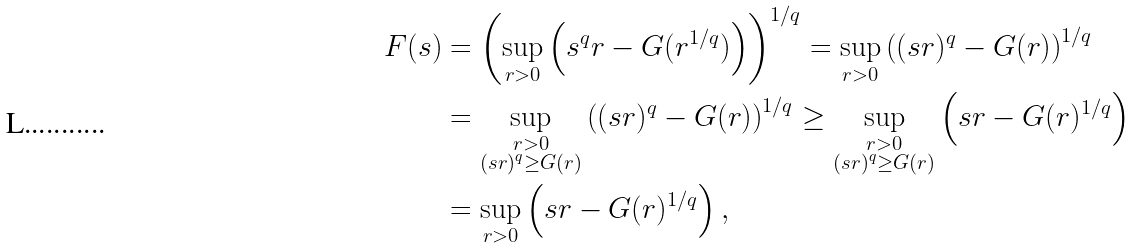Convert formula to latex. <formula><loc_0><loc_0><loc_500><loc_500>F ( s ) & = \left ( \sup _ { r > 0 } \left ( s ^ { q } r - G ( r ^ { 1 / q } ) \right ) \right ) ^ { 1 / q } = \sup _ { r > 0 } \left ( ( s r ) ^ { q } - G ( r ) \right ) ^ { 1 / q } \\ & = \sup _ { \substack { r > 0 \\ ( s r ) ^ { q } \geq G ( r ) } } \left ( ( s r ) ^ { q } - G ( r ) \right ) ^ { 1 / q } \geq \sup _ { \substack { r > 0 \\ ( s r ) ^ { q } \geq G ( r ) } } \left ( s r - G ( r ) ^ { 1 / q } \right ) \\ & = \sup _ { r > 0 } \left ( s r - G ( r ) ^ { 1 / q } \right ) ,</formula> 